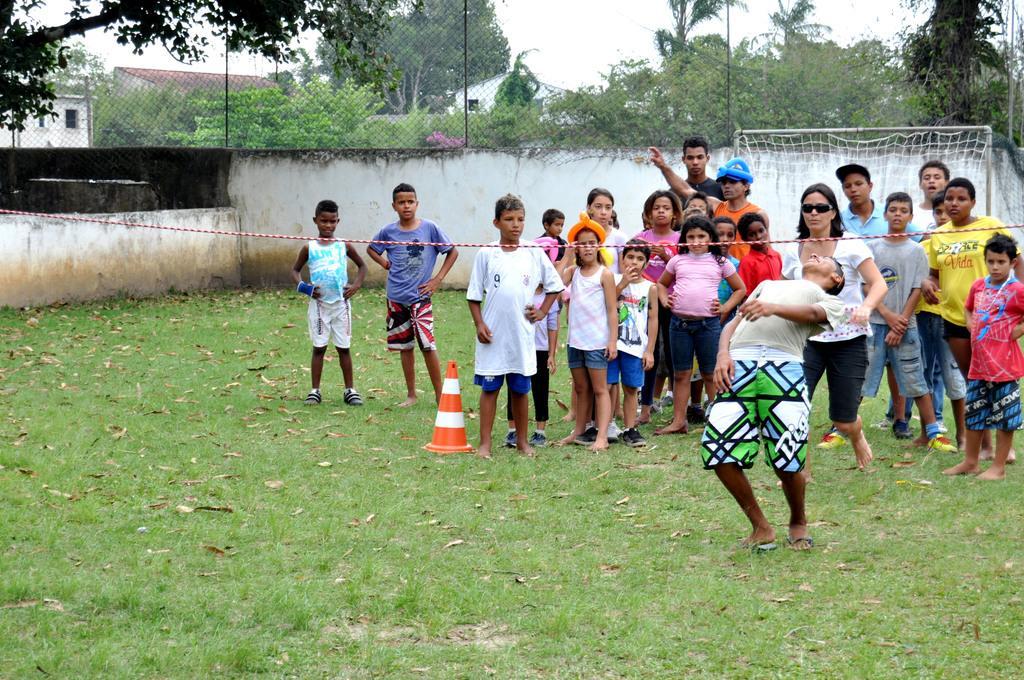Can you describe this image briefly? In the center of the image group of people are standing. In the middle of the image there is a rope and divider cone are present. In the background of the image we can see a wall, mesh trees and houses are present. At the top of the image sky is there. At the bottom of the image grass is present. 